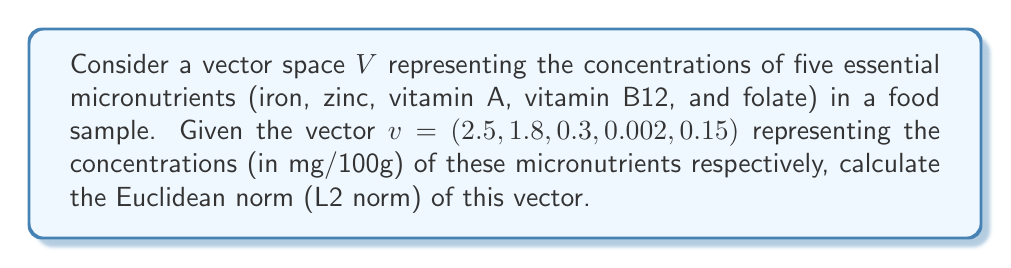Show me your answer to this math problem. To solve this problem, we need to follow these steps:

1) The Euclidean norm (also known as L2 norm) of a vector $x = (x_1, x_2, ..., x_n)$ is defined as:

   $$\|x\|_2 = \sqrt{\sum_{i=1}^n |x_i|^2}$$

2) In our case, we have:
   $v = (2.5, 1.8, 0.3, 0.002, 0.15)$

3) Let's calculate the sum of the squares of each component:

   $$\begin{align*}
   |x_1|^2 &= 2.5^2 = 6.25 \\
   |x_2|^2 &= 1.8^2 = 3.24 \\
   |x_3|^2 &= 0.3^2 = 0.09 \\
   |x_4|^2 &= 0.002^2 = 0.000004 \\
   |x_5|^2 &= 0.15^2 = 0.0225
   \end{align*}$$

4) Now, we sum these values:

   $$6.25 + 3.24 + 0.09 + 0.000004 + 0.0225 = 9.602504$$

5) Finally, we take the square root of this sum:

   $$\|v\|_2 = \sqrt{9.602504} \approx 3.0988$$

Therefore, the Euclidean norm of the vector representing the micronutrient concentrations is approximately 3.0988 mg/100g.
Answer: $\|v\|_2 \approx 3.0988$ mg/100g 